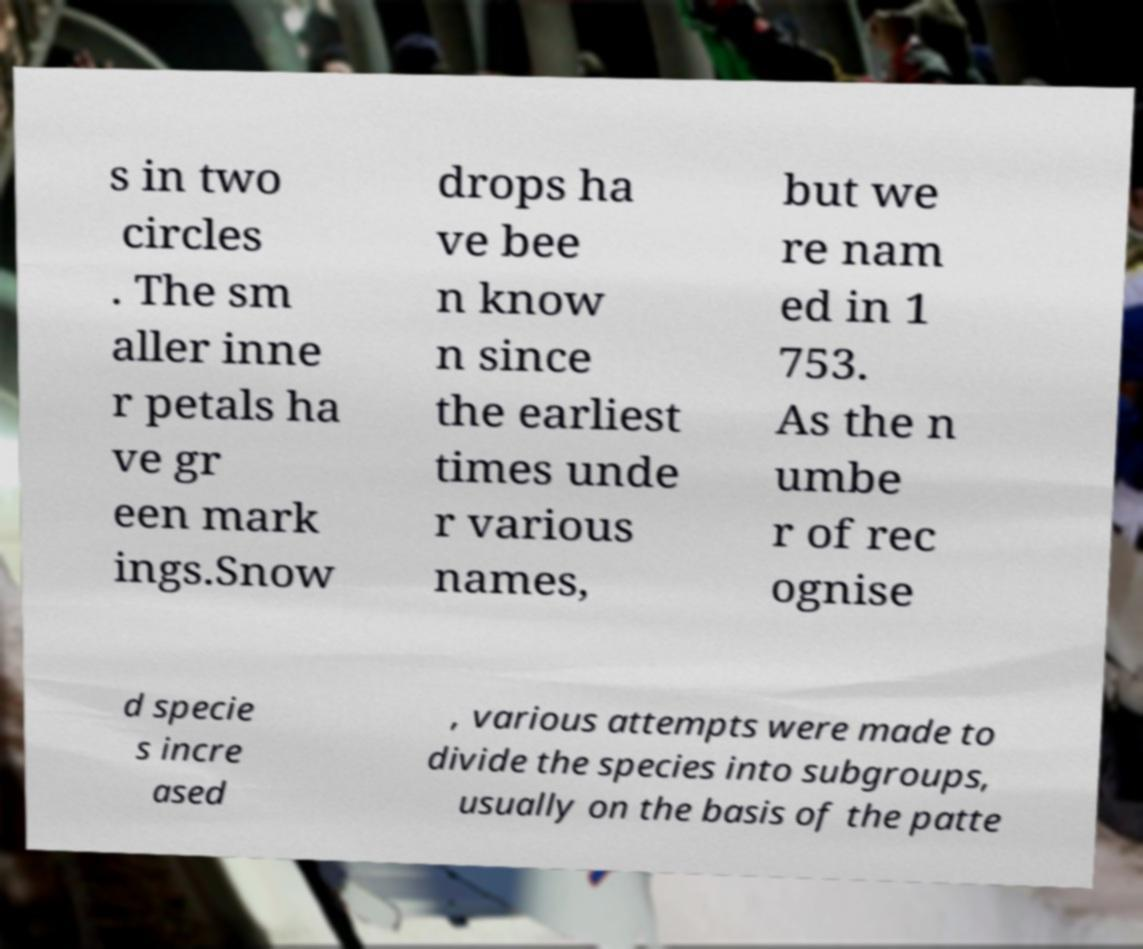Please read and relay the text visible in this image. What does it say? s in two circles . The sm aller inne r petals ha ve gr een mark ings.Snow drops ha ve bee n know n since the earliest times unde r various names, but we re nam ed in 1 753. As the n umbe r of rec ognise d specie s incre ased , various attempts were made to divide the species into subgroups, usually on the basis of the patte 